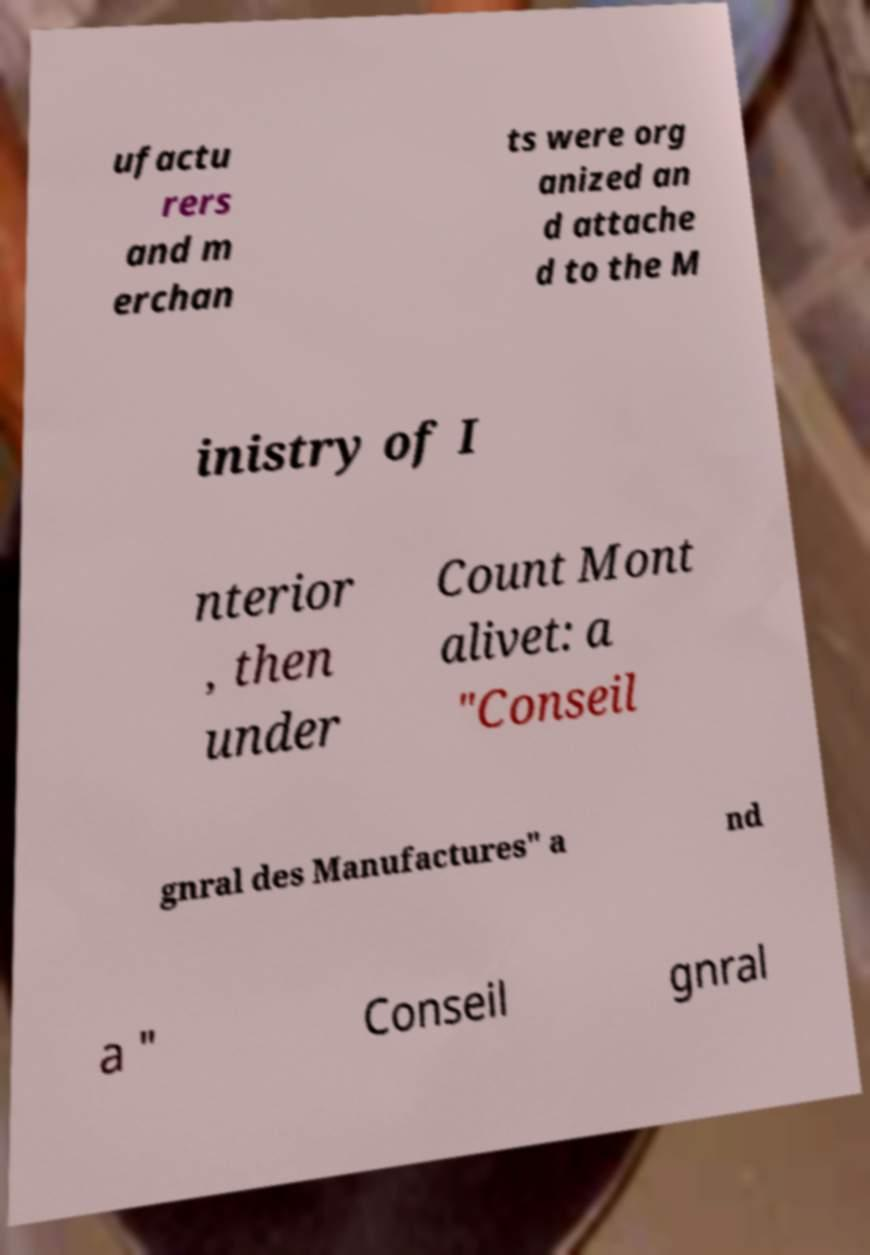For documentation purposes, I need the text within this image transcribed. Could you provide that? ufactu rers and m erchan ts were org anized an d attache d to the M inistry of I nterior , then under Count Mont alivet: a "Conseil gnral des Manufactures" a nd a " Conseil gnral 